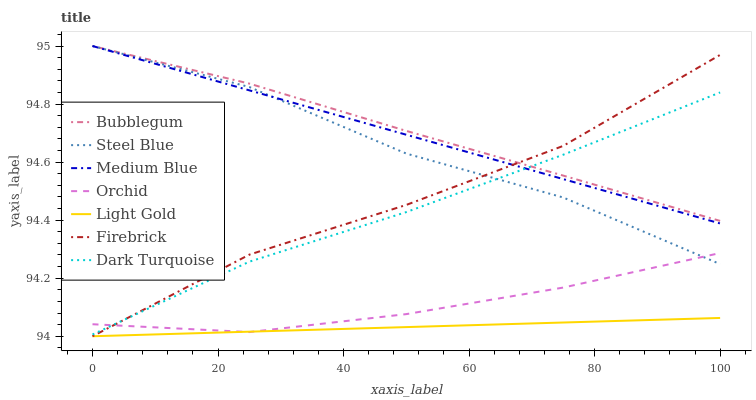Does Light Gold have the minimum area under the curve?
Answer yes or no. Yes. Does Bubblegum have the maximum area under the curve?
Answer yes or no. Yes. Does Firebrick have the minimum area under the curve?
Answer yes or no. No. Does Firebrick have the maximum area under the curve?
Answer yes or no. No. Is Light Gold the smoothest?
Answer yes or no. Yes. Is Firebrick the roughest?
Answer yes or no. Yes. Is Medium Blue the smoothest?
Answer yes or no. No. Is Medium Blue the roughest?
Answer yes or no. No. Does Firebrick have the lowest value?
Answer yes or no. Yes. Does Medium Blue have the lowest value?
Answer yes or no. No. Does Bubblegum have the highest value?
Answer yes or no. Yes. Does Firebrick have the highest value?
Answer yes or no. No. Is Light Gold less than Medium Blue?
Answer yes or no. Yes. Is Bubblegum greater than Light Gold?
Answer yes or no. Yes. Does Firebrick intersect Light Gold?
Answer yes or no. Yes. Is Firebrick less than Light Gold?
Answer yes or no. No. Is Firebrick greater than Light Gold?
Answer yes or no. No. Does Light Gold intersect Medium Blue?
Answer yes or no. No. 